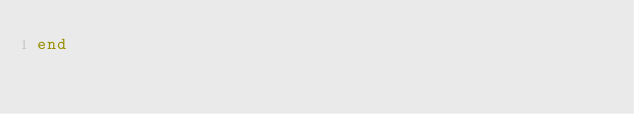<code> <loc_0><loc_0><loc_500><loc_500><_Ruby_>end
</code> 